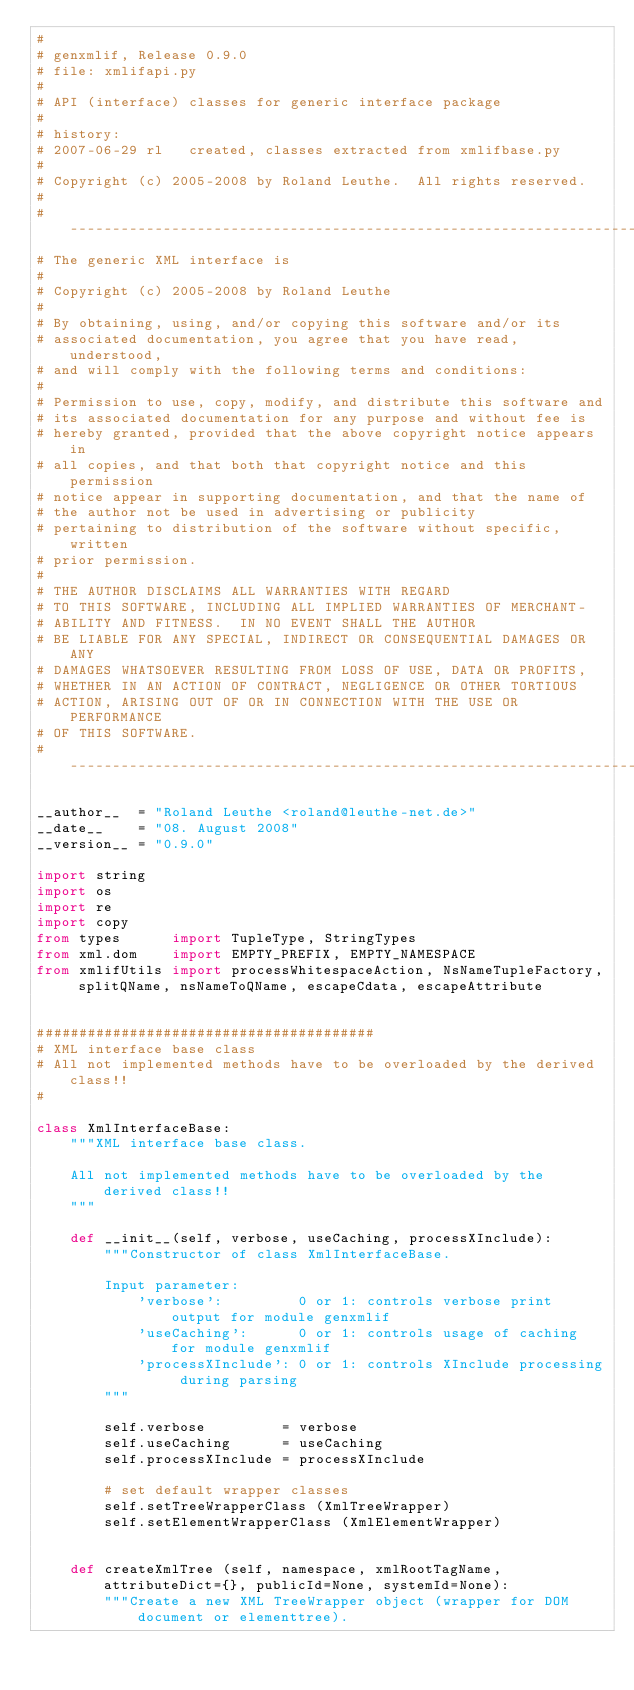Convert code to text. <code><loc_0><loc_0><loc_500><loc_500><_Python_>#
# genxmlif, Release 0.9.0
# file: xmlifapi.py
#
# API (interface) classes for generic interface package
#
# history:
# 2007-06-29 rl   created, classes extracted from xmlifbase.py
#
# Copyright (c) 2005-2008 by Roland Leuthe.  All rights reserved.
#
# --------------------------------------------------------------------
# The generic XML interface is
#
# Copyright (c) 2005-2008 by Roland Leuthe
#
# By obtaining, using, and/or copying this software and/or its
# associated documentation, you agree that you have read, understood,
# and will comply with the following terms and conditions:
#
# Permission to use, copy, modify, and distribute this software and
# its associated documentation for any purpose and without fee is
# hereby granted, provided that the above copyright notice appears in
# all copies, and that both that copyright notice and this permission
# notice appear in supporting documentation, and that the name of
# the author not be used in advertising or publicity
# pertaining to distribution of the software without specific, written
# prior permission.
#
# THE AUTHOR DISCLAIMS ALL WARRANTIES WITH REGARD
# TO THIS SOFTWARE, INCLUDING ALL IMPLIED WARRANTIES OF MERCHANT-
# ABILITY AND FITNESS.  IN NO EVENT SHALL THE AUTHOR
# BE LIABLE FOR ANY SPECIAL, INDIRECT OR CONSEQUENTIAL DAMAGES OR ANY
# DAMAGES WHATSOEVER RESULTING FROM LOSS OF USE, DATA OR PROFITS,
# WHETHER IN AN ACTION OF CONTRACT, NEGLIGENCE OR OTHER TORTIOUS
# ACTION, ARISING OUT OF OR IN CONNECTION WITH THE USE OR PERFORMANCE
# OF THIS SOFTWARE.
# --------------------------------------------------------------------

__author__  = "Roland Leuthe <roland@leuthe-net.de>"
__date__    = "08. August 2008"
__version__ = "0.9.0"

import string
import os
import re
import copy
from types      import TupleType, StringTypes
from xml.dom    import EMPTY_PREFIX, EMPTY_NAMESPACE
from xmlifUtils import processWhitespaceAction, NsNameTupleFactory, splitQName, nsNameToQName, escapeCdata, escapeAttribute


########################################
# XML interface base class
# All not implemented methods have to be overloaded by the derived class!!
#

class XmlInterfaceBase:
    """XML interface base class.
    
    All not implemented methods have to be overloaded by the derived class!!
    """

    def __init__(self, verbose, useCaching, processXInclude):
        """Constructor of class XmlInterfaceBase.
        
        Input parameter:
            'verbose':         0 or 1: controls verbose print output for module genxmlif
            'useCaching':      0 or 1: controls usage of caching for module genxmlif
            'processXInclude': 0 or 1: controls XInclude processing during parsing
        """
        
        self.verbose         = verbose
        self.useCaching      = useCaching
        self.processXInclude = processXInclude

        # set default wrapper classes
        self.setTreeWrapperClass (XmlTreeWrapper)
        self.setElementWrapperClass (XmlElementWrapper)


    def createXmlTree (self, namespace, xmlRootTagName, attributeDict={}, publicId=None, systemId=None):
        """Create a new XML TreeWrapper object (wrapper for DOM document or elementtree).
        </code> 